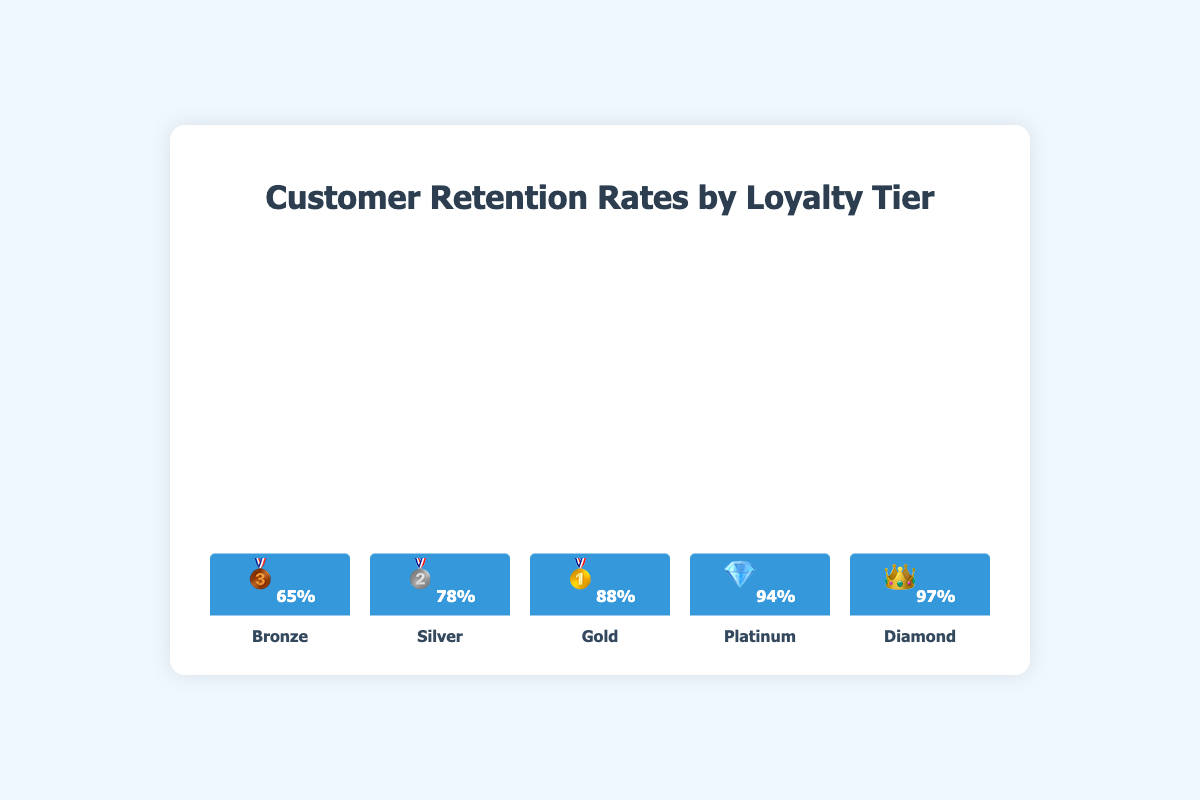what is the retention rate for the Bronze tier? The figure shows that the Bronze tier, marked with the 🥉 emoji, has a retention rate of 65%.
Answer: 65% Which loyalty tier has the highest retention rate? The figure indicates that the Diamond tier, represented by the 👑 emoji, has the highest retention rate of 97%.
Answer: Diamond How much higher is the retention rate of the Silver tier compared to the Bronze tier? The Silver tier has a retention rate of 78%, and the Bronze has a retention rate of 65%. The difference is 78% - 65% = 13%.
Answer: 13% Which loyalty tier is represented by the 💎 emoji and what is its retention rate? The figure shows that the 💎 emoji represents the Platinum tier, which has a retention rate of 94%.
Answer: Platinum, 94% Arrange the loyalty tiers in ascending order based on their retention rates. From the figure, the retention rates in ascending order are: Bronze (65%), Silver (78%), Gold (88%), Platinum (94%), Diamond (97%).
Answer: Bronze, Silver, Gold, Platinum, Diamond What is the average retention rate of the Gold and Platinum tiers? The retention rates for Gold and Platinum are 88% and 94%, respectively. The average is (88% + 94%) / 2 = 91%.
Answer: 91% Which tier shows a retention rate closest to 90%? Among the tiers, the Gold tier has a retention rate of 88%, which is the closest to 90%.
Answer: Gold What is the difference in retention rate between the tiers with the highest and lowest retention rates? The Diamond tier has the highest retention rate (97%), and the Bronze tier has the lowest (65%). The difference is 97% - 65% = 32%.
Answer: 32% If we consider Bronze and Silver to be lower tiers and Gold, Platinum, and Diamond to be higher tiers, what is the average retention rate for each group? Lower tiers (Bronze, Silver): (65% + 78%) / 2 = 71.5%. Higher tiers (Gold, Platinum, Diamond): (88% + 94% + 97%) / 3 = 93%.
Answer: Lower: 71.5%, Higher: 93% Are the retention rates for all tiers displayed in the figure above 60%? The figure shows the retention rates for all tiers, and the lowest value, for Bronze, is 65%, which is above 60%.
Answer: Yes 